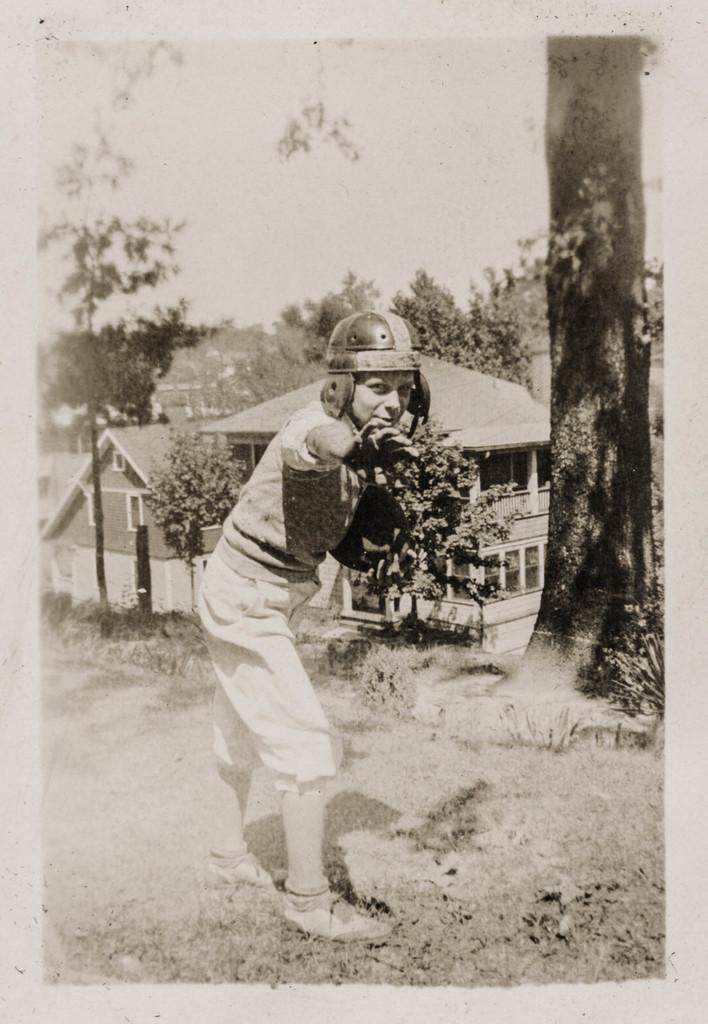Describe this image in one or two sentences. In the foreground of the image we can see a boy wearing helmet. In the middle of the image we can see trees and building. On the top of the image we can see the sky. By seeing this image we can say it is a photograph. 